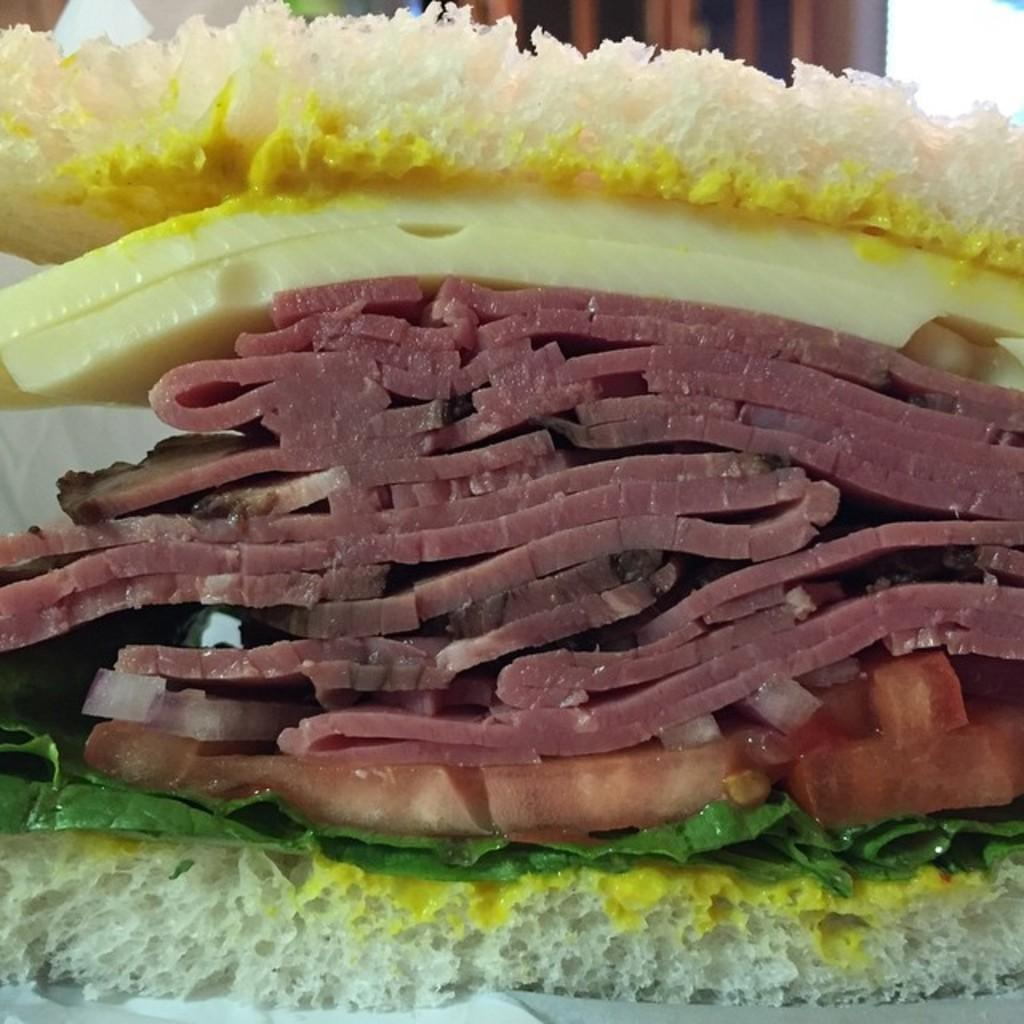What type of food is the main subject of the image? There is a sandwich in the image. How many layers of bread are in the sandwich? The sandwich has two bread layers. What ingredients are present in the sandwich? The sandwich contains cheese, meat pieces, and leaves. What type of car can be seen in the image? There is no car present in the image; it features a sandwich with cheese, meat pieces, and leaves. What type of thread is used to hold the sandwich together? There is no thread visible in the image; the sandwich layers are held together by the bread. 